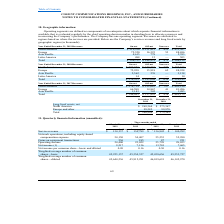According to Cogent Communications Group's financial document, What is the value revenue from the on-net segment from North America in 2019? According to the financial document, $319,330 (in thousands). The relevant text states: "ues On-net Off-net Non-core Total North America $ 319,330 $ 131,815 $ 422 $ 451,567 Europe 72,320 16,323 53 88,696 Asia Pacific 4,615 778 — 5,393 Latin Ameri..." Also, What is the value revenue from the off-net segment from North America in 2019? According to the financial document, $131,815 (in thousands). The relevant text states: "Off-net Non-core Total North America $ 319,330 $ 131,815 $ 422 $ 451,567 Europe 72,320 16,323 53 88,696 Asia Pacific 4,615 778 — 5,393 Latin America 488 15..." Also, What is the value revenue from non-core segment from North America in 2019? According to the financial document, $422 (in thousands). The relevant text states: "on-core Total North America $ 319,330 $ 131,815 $ 422 $ 451,567 Europe 72,320 16,323 53 88,696 Asia Pacific 4,615 778 — 5,393 Latin America 488 15 — 503..." Also, can you calculate: What is the value of the revenue from the on-net segment from North America as a percentage of the total revenue earned in North America in 2019? Based on the calculation: 319,330/402,194 , the result is 79.4 (percentage). This is based on the information: "ues On-net Off-net Non-core Total North America $ 319,330 $ 131,815 $ 422 $ 451,567 Europe 72,320 16,323 53 88,696 Asia Pacific 4,615 778 — 5,393 Latin Ameri e Total North America $ 278,714 $ 122,683 ..." The key data points involved are: 319,330, 402,194. Also, can you calculate: What is the value of the revenue from the off-net segment from North America as a percentage of the total revenue earned in North America in 2019? Based on the calculation: 131,815/402,194 , the result is 32.77 (percentage). This is based on the information: "Off-net Non-core Total North America $ 319,330 $ 131,815 $ 422 $ 451,567 Europe 72,320 16,323 53 88,696 Asia Pacific 4,615 778 — 5,393 Latin America 488 15 e Total North America $ 278,714 $ 122,683 $ ..." The key data points involved are: 131,815, 402,194. Also, can you calculate: What is the value of the revenue from the non-core segment from North America as a percentage of the total revenue earned in North America in 2019? Based on the calculation: 422/402,194 , the result is 0.1 (percentage). This is based on the information: "e Total North America $ 278,714 $ 122,683 $ 797 $ 402,194 Europe 66,588 14,867 41 81,496 Asia Pacific 1,143 342 — 1,485 Total $ 346,445 $ 137,892 $ 838 $ 485 on-core Total North America $ 319,330 $ 13..." The key data points involved are: 402,194, 422. 